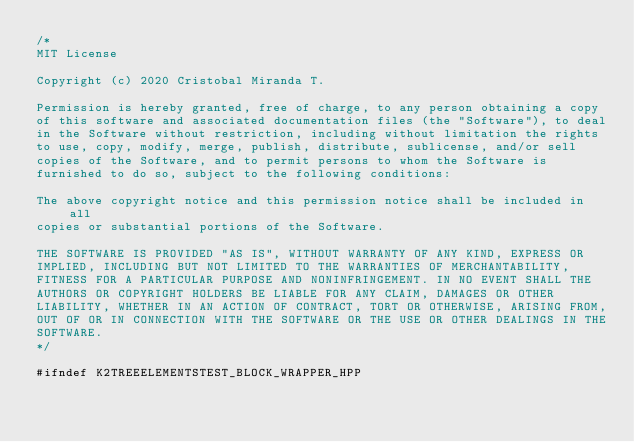<code> <loc_0><loc_0><loc_500><loc_500><_C++_>/*
MIT License

Copyright (c) 2020 Cristobal Miranda T.

Permission is hereby granted, free of charge, to any person obtaining a copy
of this software and associated documentation files (the "Software"), to deal
in the Software without restriction, including without limitation the rights
to use, copy, modify, merge, publish, distribute, sublicense, and/or sell
copies of the Software, and to permit persons to whom the Software is
furnished to do so, subject to the following conditions:

The above copyright notice and this permission notice shall be included in all
copies or substantial portions of the Software.

THE SOFTWARE IS PROVIDED "AS IS", WITHOUT WARRANTY OF ANY KIND, EXPRESS OR
IMPLIED, INCLUDING BUT NOT LIMITED TO THE WARRANTIES OF MERCHANTABILITY,
FITNESS FOR A PARTICULAR PURPOSE AND NONINFRINGEMENT. IN NO EVENT SHALL THE
AUTHORS OR COPYRIGHT HOLDERS BE LIABLE FOR ANY CLAIM, DAMAGES OR OTHER
LIABILITY, WHETHER IN AN ACTION OF CONTRACT, TORT OR OTHERWISE, ARISING FROM,
OUT OF OR IN CONNECTION WITH THE SOFTWARE OR THE USE OR OTHER DEALINGS IN THE
SOFTWARE.
*/

#ifndef K2TREEELEMENTSTEST_BLOCK_WRAPPER_HPP</code> 